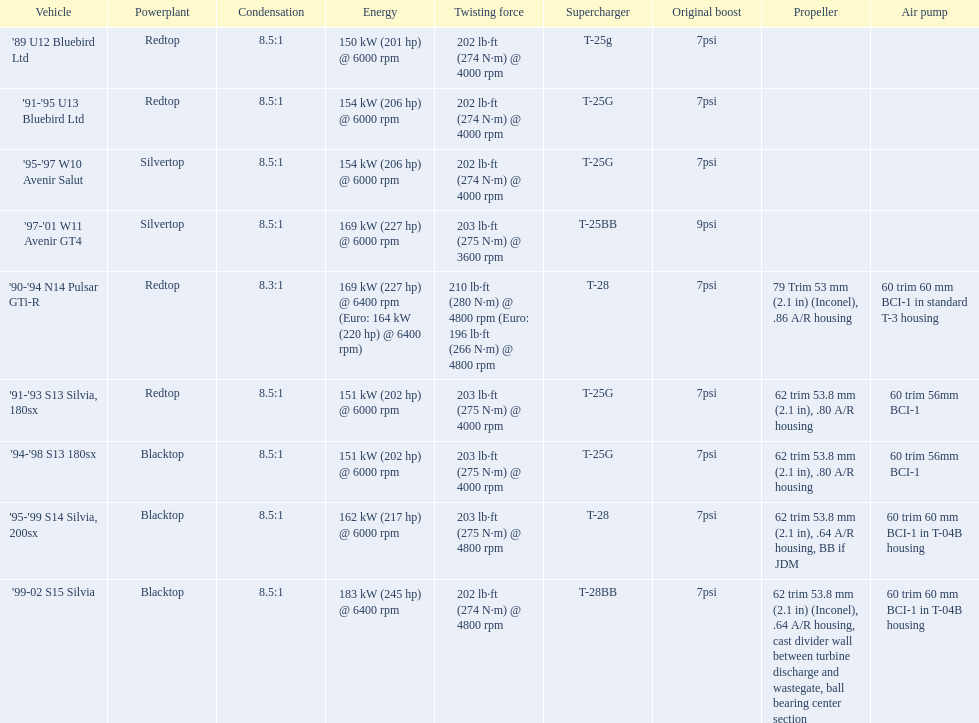Which of the cars uses the redtop engine? '89 U12 Bluebird Ltd, '91-'95 U13 Bluebird Ltd, '90-'94 N14 Pulsar GTi-R, '91-'93 S13 Silvia, 180sx. Of these, has more than 220 horsepower? '90-'94 N14 Pulsar GTi-R. What is the compression ratio of this car? 8.3:1. 